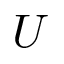Convert formula to latex. <formula><loc_0><loc_0><loc_500><loc_500>U</formula> 